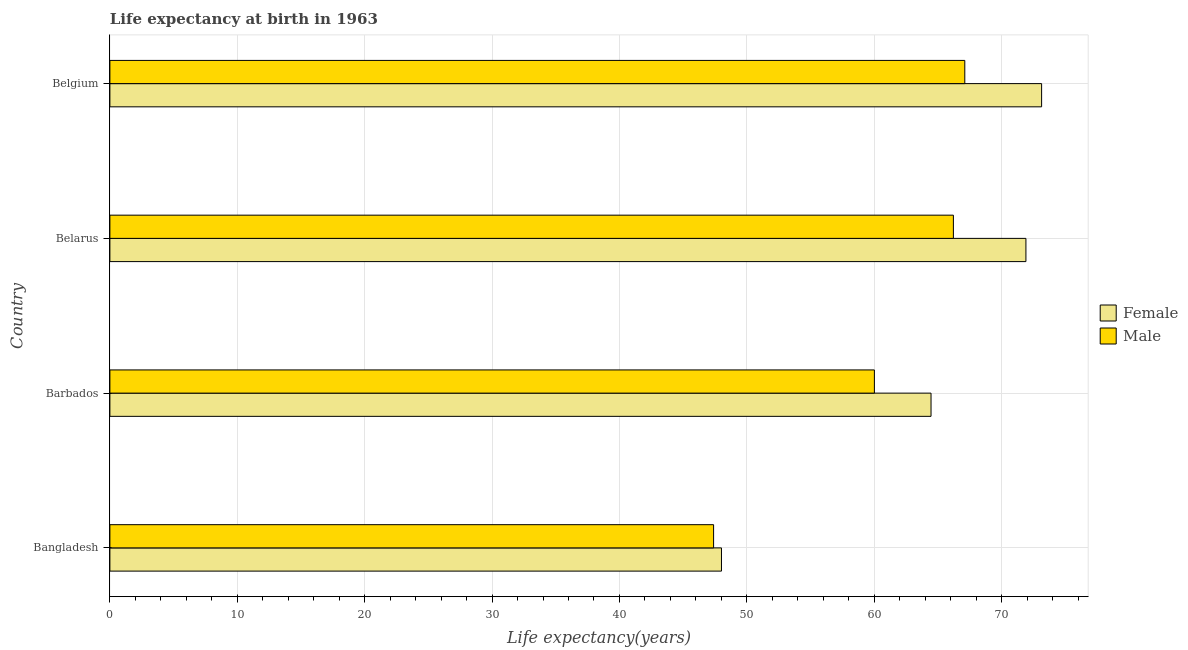How many different coloured bars are there?
Give a very brief answer. 2. How many groups of bars are there?
Offer a terse response. 4. How many bars are there on the 1st tick from the top?
Give a very brief answer. 2. What is the label of the 3rd group of bars from the top?
Provide a short and direct response. Barbados. What is the life expectancy(male) in Belarus?
Your answer should be very brief. 66.22. Across all countries, what is the maximum life expectancy(male)?
Provide a short and direct response. 67.11. Across all countries, what is the minimum life expectancy(female)?
Your response must be concise. 48.01. What is the total life expectancy(male) in the graph?
Ensure brevity in your answer.  240.73. What is the difference between the life expectancy(male) in Barbados and that in Belgium?
Keep it short and to the point. -7.1. What is the difference between the life expectancy(male) in Bangladesh and the life expectancy(female) in Barbados?
Offer a terse response. -17.07. What is the average life expectancy(female) per country?
Ensure brevity in your answer.  64.38. What is the difference between the life expectancy(female) and life expectancy(male) in Belgium?
Give a very brief answer. 6.03. In how many countries, is the life expectancy(female) greater than 8 years?
Provide a short and direct response. 4. What is the ratio of the life expectancy(female) in Bangladesh to that in Belgium?
Offer a very short reply. 0.66. Is the life expectancy(male) in Bangladesh less than that in Belgium?
Ensure brevity in your answer.  Yes. What is the difference between the highest and the second highest life expectancy(female)?
Ensure brevity in your answer.  1.23. What is the difference between the highest and the lowest life expectancy(female)?
Your answer should be compact. 25.13. In how many countries, is the life expectancy(male) greater than the average life expectancy(male) taken over all countries?
Your response must be concise. 2. Is the sum of the life expectancy(male) in Bangladesh and Barbados greater than the maximum life expectancy(female) across all countries?
Ensure brevity in your answer.  Yes. What does the 2nd bar from the bottom in Barbados represents?
Provide a short and direct response. Male. Are all the bars in the graph horizontal?
Offer a terse response. Yes. What is the difference between two consecutive major ticks on the X-axis?
Provide a short and direct response. 10. Are the values on the major ticks of X-axis written in scientific E-notation?
Keep it short and to the point. No. Where does the legend appear in the graph?
Provide a short and direct response. Center right. How many legend labels are there?
Give a very brief answer. 2. What is the title of the graph?
Provide a succinct answer. Life expectancy at birth in 1963. What is the label or title of the X-axis?
Ensure brevity in your answer.  Life expectancy(years). What is the Life expectancy(years) in Female in Bangladesh?
Make the answer very short. 48.01. What is the Life expectancy(years) of Male in Bangladesh?
Your response must be concise. 47.39. What is the Life expectancy(years) in Female in Barbados?
Make the answer very short. 64.46. What is the Life expectancy(years) of Male in Barbados?
Offer a terse response. 60.01. What is the Life expectancy(years) in Female in Belarus?
Keep it short and to the point. 71.91. What is the Life expectancy(years) of Male in Belarus?
Offer a very short reply. 66.22. What is the Life expectancy(years) of Female in Belgium?
Give a very brief answer. 73.14. What is the Life expectancy(years) in Male in Belgium?
Ensure brevity in your answer.  67.11. Across all countries, what is the maximum Life expectancy(years) of Female?
Your answer should be compact. 73.14. Across all countries, what is the maximum Life expectancy(years) in Male?
Offer a terse response. 67.11. Across all countries, what is the minimum Life expectancy(years) in Female?
Give a very brief answer. 48.01. Across all countries, what is the minimum Life expectancy(years) of Male?
Your answer should be very brief. 47.39. What is the total Life expectancy(years) of Female in the graph?
Keep it short and to the point. 257.52. What is the total Life expectancy(years) of Male in the graph?
Give a very brief answer. 240.73. What is the difference between the Life expectancy(years) in Female in Bangladesh and that in Barbados?
Your answer should be compact. -16.45. What is the difference between the Life expectancy(years) in Male in Bangladesh and that in Barbados?
Your answer should be compact. -12.62. What is the difference between the Life expectancy(years) of Female in Bangladesh and that in Belarus?
Offer a terse response. -23.9. What is the difference between the Life expectancy(years) of Male in Bangladesh and that in Belarus?
Offer a terse response. -18.82. What is the difference between the Life expectancy(years) in Female in Bangladesh and that in Belgium?
Offer a terse response. -25.13. What is the difference between the Life expectancy(years) in Male in Bangladesh and that in Belgium?
Offer a terse response. -19.72. What is the difference between the Life expectancy(years) of Female in Barbados and that in Belarus?
Your answer should be very brief. -7.45. What is the difference between the Life expectancy(years) in Male in Barbados and that in Belarus?
Make the answer very short. -6.2. What is the difference between the Life expectancy(years) in Female in Barbados and that in Belgium?
Give a very brief answer. -8.68. What is the difference between the Life expectancy(years) in Male in Barbados and that in Belgium?
Ensure brevity in your answer.  -7.1. What is the difference between the Life expectancy(years) of Female in Belarus and that in Belgium?
Your answer should be compact. -1.23. What is the difference between the Life expectancy(years) in Male in Belarus and that in Belgium?
Offer a terse response. -0.9. What is the difference between the Life expectancy(years) of Female in Bangladesh and the Life expectancy(years) of Male in Barbados?
Your answer should be very brief. -12. What is the difference between the Life expectancy(years) of Female in Bangladesh and the Life expectancy(years) of Male in Belarus?
Your answer should be compact. -18.21. What is the difference between the Life expectancy(years) of Female in Bangladesh and the Life expectancy(years) of Male in Belgium?
Make the answer very short. -19.1. What is the difference between the Life expectancy(years) of Female in Barbados and the Life expectancy(years) of Male in Belarus?
Offer a very short reply. -1.75. What is the difference between the Life expectancy(years) of Female in Barbados and the Life expectancy(years) of Male in Belgium?
Give a very brief answer. -2.65. What is the difference between the Life expectancy(years) of Female in Belarus and the Life expectancy(years) of Male in Belgium?
Ensure brevity in your answer.  4.8. What is the average Life expectancy(years) in Female per country?
Provide a short and direct response. 64.38. What is the average Life expectancy(years) of Male per country?
Give a very brief answer. 60.18. What is the difference between the Life expectancy(years) of Female and Life expectancy(years) of Male in Bangladesh?
Offer a very short reply. 0.62. What is the difference between the Life expectancy(years) in Female and Life expectancy(years) in Male in Barbados?
Ensure brevity in your answer.  4.45. What is the difference between the Life expectancy(years) in Female and Life expectancy(years) in Male in Belarus?
Offer a terse response. 5.69. What is the difference between the Life expectancy(years) of Female and Life expectancy(years) of Male in Belgium?
Keep it short and to the point. 6.03. What is the ratio of the Life expectancy(years) of Female in Bangladesh to that in Barbados?
Provide a succinct answer. 0.74. What is the ratio of the Life expectancy(years) of Male in Bangladesh to that in Barbados?
Offer a very short reply. 0.79. What is the ratio of the Life expectancy(years) in Female in Bangladesh to that in Belarus?
Your answer should be compact. 0.67. What is the ratio of the Life expectancy(years) in Male in Bangladesh to that in Belarus?
Provide a succinct answer. 0.72. What is the ratio of the Life expectancy(years) of Female in Bangladesh to that in Belgium?
Offer a terse response. 0.66. What is the ratio of the Life expectancy(years) of Male in Bangladesh to that in Belgium?
Your response must be concise. 0.71. What is the ratio of the Life expectancy(years) of Female in Barbados to that in Belarus?
Provide a succinct answer. 0.9. What is the ratio of the Life expectancy(years) of Male in Barbados to that in Belarus?
Ensure brevity in your answer.  0.91. What is the ratio of the Life expectancy(years) in Female in Barbados to that in Belgium?
Provide a succinct answer. 0.88. What is the ratio of the Life expectancy(years) in Male in Barbados to that in Belgium?
Ensure brevity in your answer.  0.89. What is the ratio of the Life expectancy(years) of Female in Belarus to that in Belgium?
Keep it short and to the point. 0.98. What is the ratio of the Life expectancy(years) in Male in Belarus to that in Belgium?
Keep it short and to the point. 0.99. What is the difference between the highest and the second highest Life expectancy(years) of Female?
Your response must be concise. 1.23. What is the difference between the highest and the second highest Life expectancy(years) in Male?
Your answer should be very brief. 0.9. What is the difference between the highest and the lowest Life expectancy(years) of Female?
Your answer should be compact. 25.13. What is the difference between the highest and the lowest Life expectancy(years) of Male?
Make the answer very short. 19.72. 